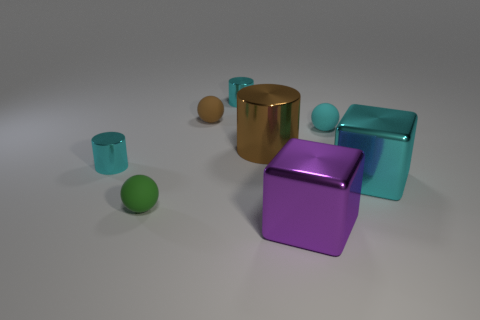Subtract all big brown cylinders. How many cylinders are left? 2 Subtract 1 balls. How many balls are left? 2 Add 1 cyan shiny cubes. How many objects exist? 9 Subtract all brown balls. How many balls are left? 2 Add 7 large cyan shiny blocks. How many large cyan shiny blocks are left? 8 Add 4 blocks. How many blocks exist? 6 Subtract 0 green cylinders. How many objects are left? 8 Subtract all balls. How many objects are left? 5 Subtract all yellow cubes. Subtract all green balls. How many cubes are left? 2 Subtract all blue cylinders. How many purple cubes are left? 1 